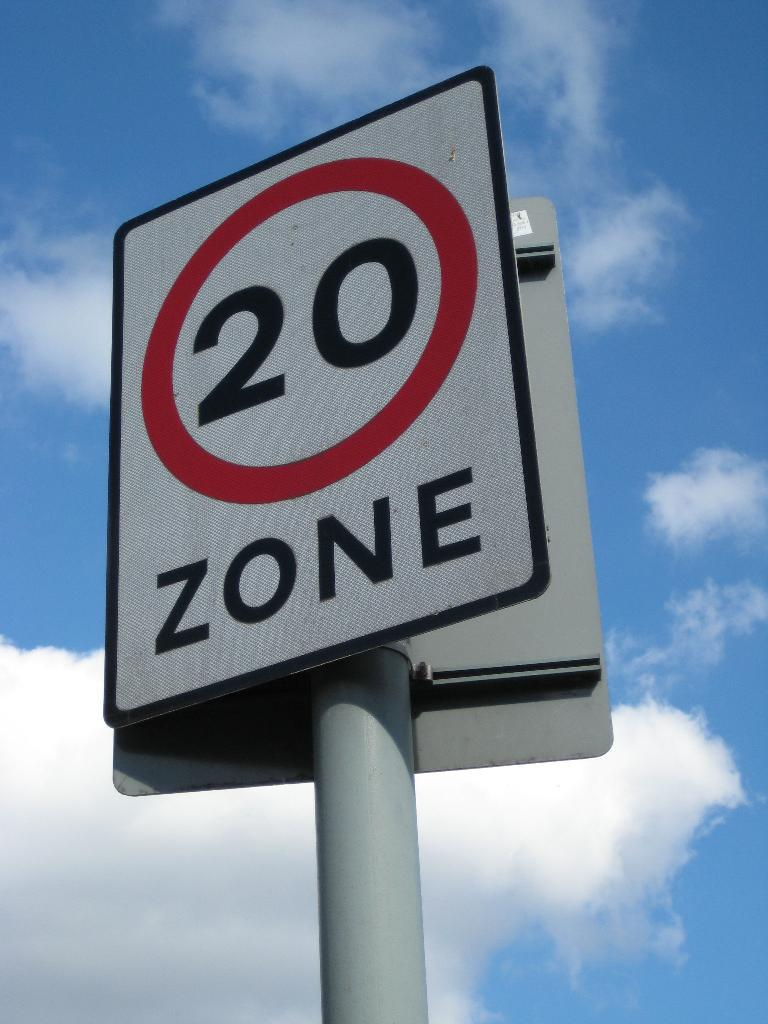<image>
Summarize the visual content of the image. a sign outide with a red circle on it and the number '20' and word 'zone' on it 